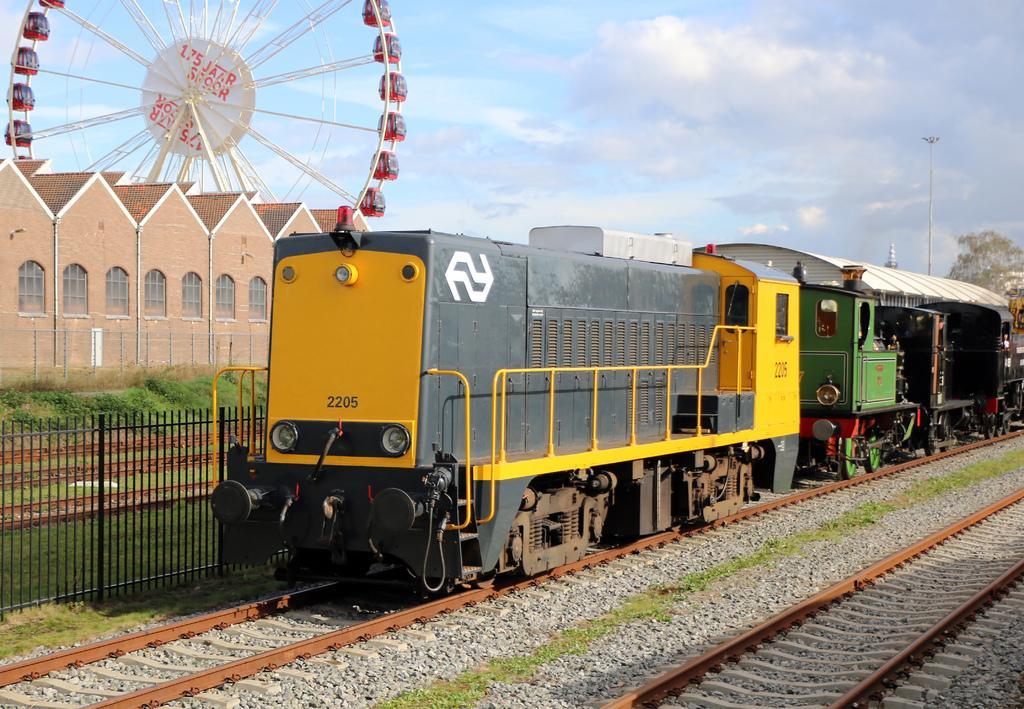How would you summarize this image in a sentence or two? We can see train on track and we can see railway tracks and fence. Background we can see building,tree,giant wheel,poles and sky. 